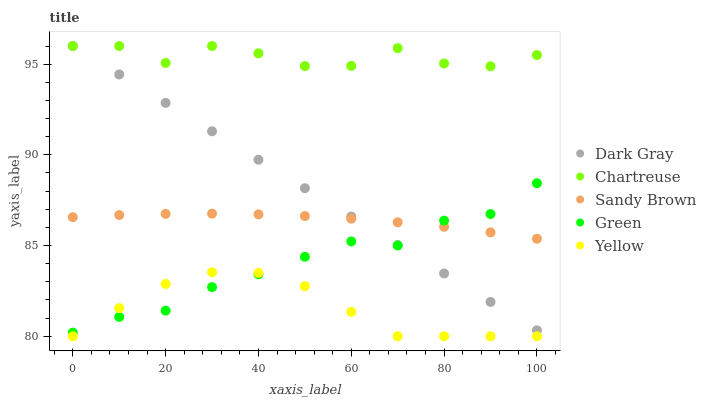Does Yellow have the minimum area under the curve?
Answer yes or no. Yes. Does Chartreuse have the maximum area under the curve?
Answer yes or no. Yes. Does Green have the minimum area under the curve?
Answer yes or no. No. Does Green have the maximum area under the curve?
Answer yes or no. No. Is Dark Gray the smoothest?
Answer yes or no. Yes. Is Chartreuse the roughest?
Answer yes or no. Yes. Is Green the smoothest?
Answer yes or no. No. Is Green the roughest?
Answer yes or no. No. Does Yellow have the lowest value?
Answer yes or no. Yes. Does Green have the lowest value?
Answer yes or no. No. Does Chartreuse have the highest value?
Answer yes or no. Yes. Does Green have the highest value?
Answer yes or no. No. Is Green less than Chartreuse?
Answer yes or no. Yes. Is Chartreuse greater than Sandy Brown?
Answer yes or no. Yes. Does Sandy Brown intersect Green?
Answer yes or no. Yes. Is Sandy Brown less than Green?
Answer yes or no. No. Is Sandy Brown greater than Green?
Answer yes or no. No. Does Green intersect Chartreuse?
Answer yes or no. No. 